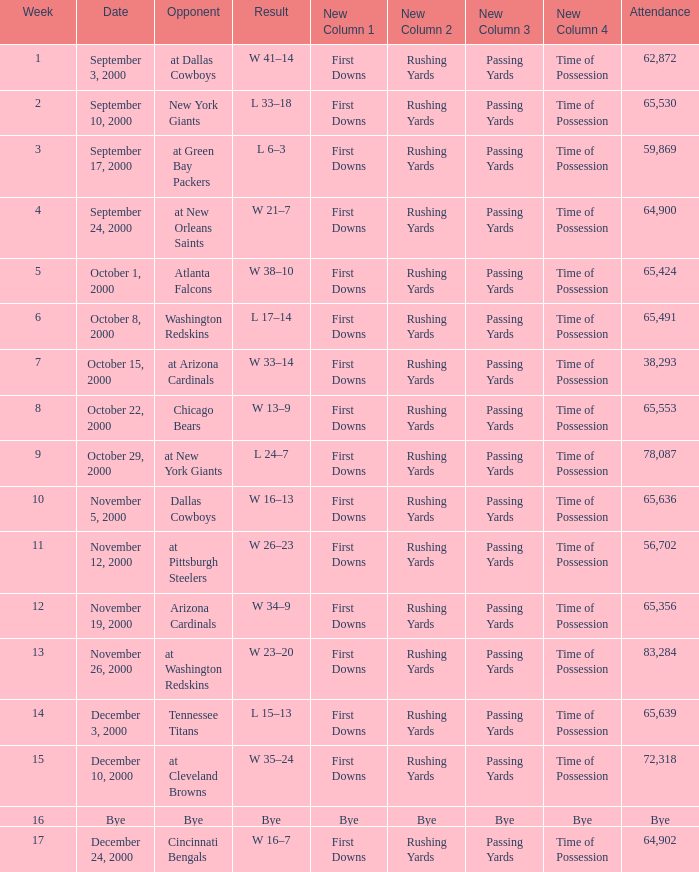What was the attendance for week 2? 65530.0. Could you parse the entire table as a dict? {'header': ['Week', 'Date', 'Opponent', 'Result', 'New Column 1', 'New Column 2', 'New Column 3', 'New Column 4', 'Attendance'], 'rows': [['1', 'September 3, 2000', 'at Dallas Cowboys', 'W 41–14', 'First Downs', 'Rushing Yards', 'Passing Yards', 'Time of Possession', '62,872'], ['2', 'September 10, 2000', 'New York Giants', 'L 33–18', 'First Downs', 'Rushing Yards', 'Passing Yards', 'Time of Possession', '65,530'], ['3', 'September 17, 2000', 'at Green Bay Packers', 'L 6–3', 'First Downs', 'Rushing Yards', 'Passing Yards', 'Time of Possession', '59,869'], ['4', 'September 24, 2000', 'at New Orleans Saints', 'W 21–7', 'First Downs', 'Rushing Yards', 'Passing Yards', 'Time of Possession', '64,900'], ['5', 'October 1, 2000', 'Atlanta Falcons', 'W 38–10', 'First Downs', 'Rushing Yards', 'Passing Yards', 'Time of Possession', '65,424'], ['6', 'October 8, 2000', 'Washington Redskins', 'L 17–14', 'First Downs', 'Rushing Yards', 'Passing Yards', 'Time of Possession', '65,491'], ['7', 'October 15, 2000', 'at Arizona Cardinals', 'W 33–14', 'First Downs', 'Rushing Yards', 'Passing Yards', 'Time of Possession', '38,293'], ['8', 'October 22, 2000', 'Chicago Bears', 'W 13–9', 'First Downs', 'Rushing Yards', 'Passing Yards', 'Time of Possession', '65,553'], ['9', 'October 29, 2000', 'at New York Giants', 'L 24–7', 'First Downs', 'Rushing Yards', 'Passing Yards', 'Time of Possession', '78,087'], ['10', 'November 5, 2000', 'Dallas Cowboys', 'W 16–13', 'First Downs', 'Rushing Yards', 'Passing Yards', 'Time of Possession', '65,636'], ['11', 'November 12, 2000', 'at Pittsburgh Steelers', 'W 26–23', 'First Downs', 'Rushing Yards', 'Passing Yards', 'Time of Possession', '56,702'], ['12', 'November 19, 2000', 'Arizona Cardinals', 'W 34–9', 'First Downs', 'Rushing Yards', 'Passing Yards', 'Time of Possession', '65,356'], ['13', 'November 26, 2000', 'at Washington Redskins', 'W 23–20', 'First Downs', 'Rushing Yards', 'Passing Yards', 'Time of Possession', '83,284'], ['14', 'December 3, 2000', 'Tennessee Titans', 'L 15–13', 'First Downs', 'Rushing Yards', 'Passing Yards', 'Time of Possession', '65,639'], ['15', 'December 10, 2000', 'at Cleveland Browns', 'W 35–24', 'First Downs', 'Rushing Yards', 'Passing Yards', 'Time of Possession', '72,318'], ['16', 'Bye', 'Bye', 'Bye', 'Bye', 'Bye', 'Bye', 'Bye', 'Bye'], ['17', 'December 24, 2000', 'Cincinnati Bengals', 'W 16–7', 'First Downs', 'Rushing Yards', 'Passing Yards', 'Time of Possession', '64,902']]} 